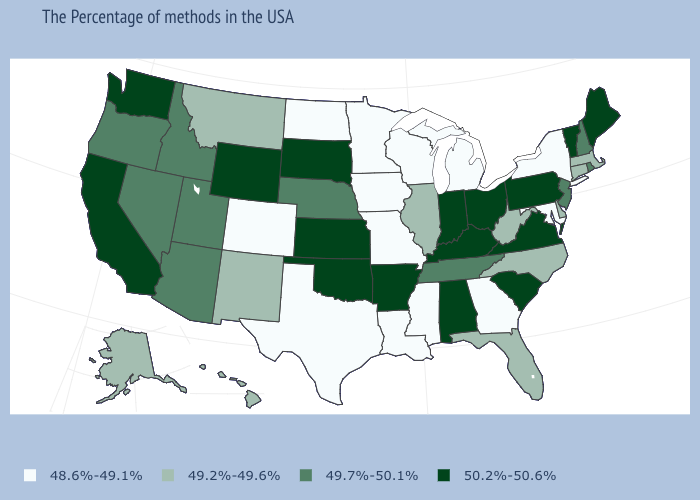What is the value of South Carolina?
Short answer required. 50.2%-50.6%. Name the states that have a value in the range 49.7%-50.1%?
Short answer required. Rhode Island, New Hampshire, New Jersey, Tennessee, Nebraska, Utah, Arizona, Idaho, Nevada, Oregon. What is the value of California?
Write a very short answer. 50.2%-50.6%. What is the value of Ohio?
Quick response, please. 50.2%-50.6%. Does South Carolina have the highest value in the South?
Be succinct. Yes. What is the value of New Jersey?
Concise answer only. 49.7%-50.1%. What is the value of North Dakota?
Concise answer only. 48.6%-49.1%. Does California have the highest value in the West?
Answer briefly. Yes. Does Pennsylvania have the highest value in the Northeast?
Quick response, please. Yes. Among the states that border Delaware , which have the lowest value?
Concise answer only. Maryland. Does the map have missing data?
Keep it brief. No. Name the states that have a value in the range 48.6%-49.1%?
Give a very brief answer. New York, Maryland, Georgia, Michigan, Wisconsin, Mississippi, Louisiana, Missouri, Minnesota, Iowa, Texas, North Dakota, Colorado. Does the map have missing data?
Concise answer only. No. Does South Dakota have the lowest value in the USA?
Give a very brief answer. No. What is the highest value in the USA?
Write a very short answer. 50.2%-50.6%. 